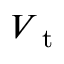<formula> <loc_0><loc_0><loc_500><loc_500>V _ { t }</formula> 